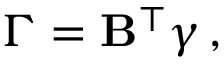Convert formula to latex. <formula><loc_0><loc_0><loc_500><loc_500>\Gamma = B ^ { \intercal } \gamma \, ,</formula> 